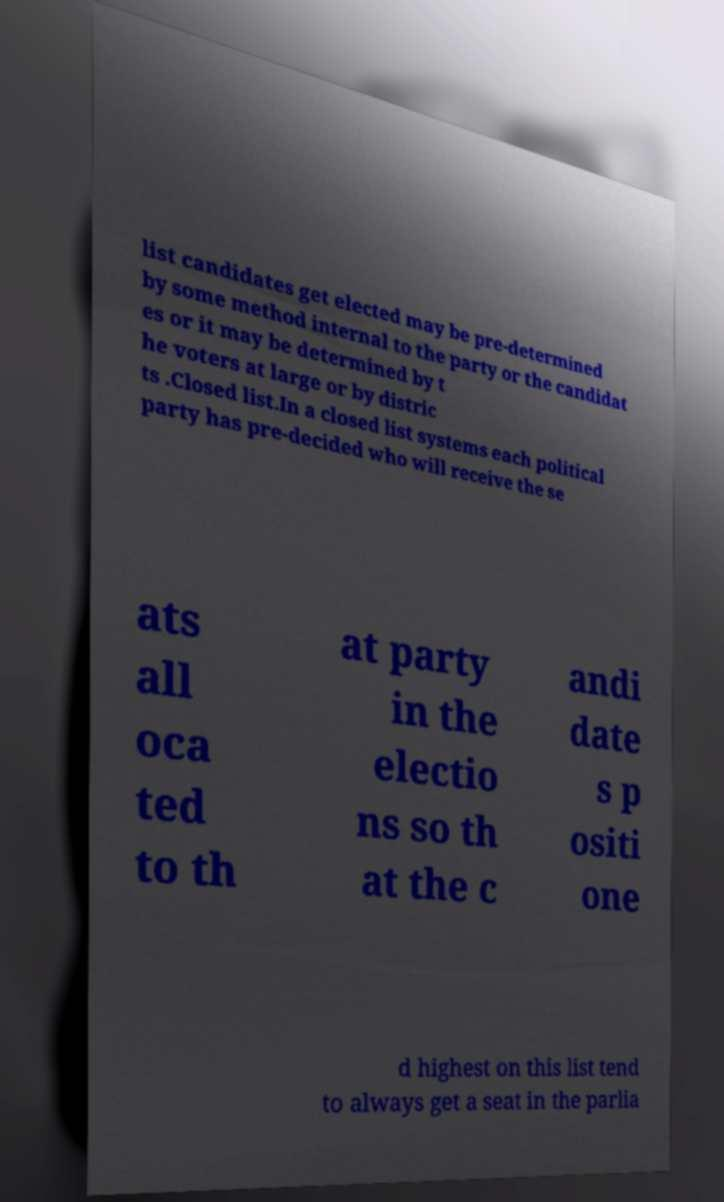There's text embedded in this image that I need extracted. Can you transcribe it verbatim? list candidates get elected may be pre-determined by some method internal to the party or the candidat es or it may be determined by t he voters at large or by distric ts .Closed list.In a closed list systems each political party has pre-decided who will receive the se ats all oca ted to th at party in the electio ns so th at the c andi date s p ositi one d highest on this list tend to always get a seat in the parlia 